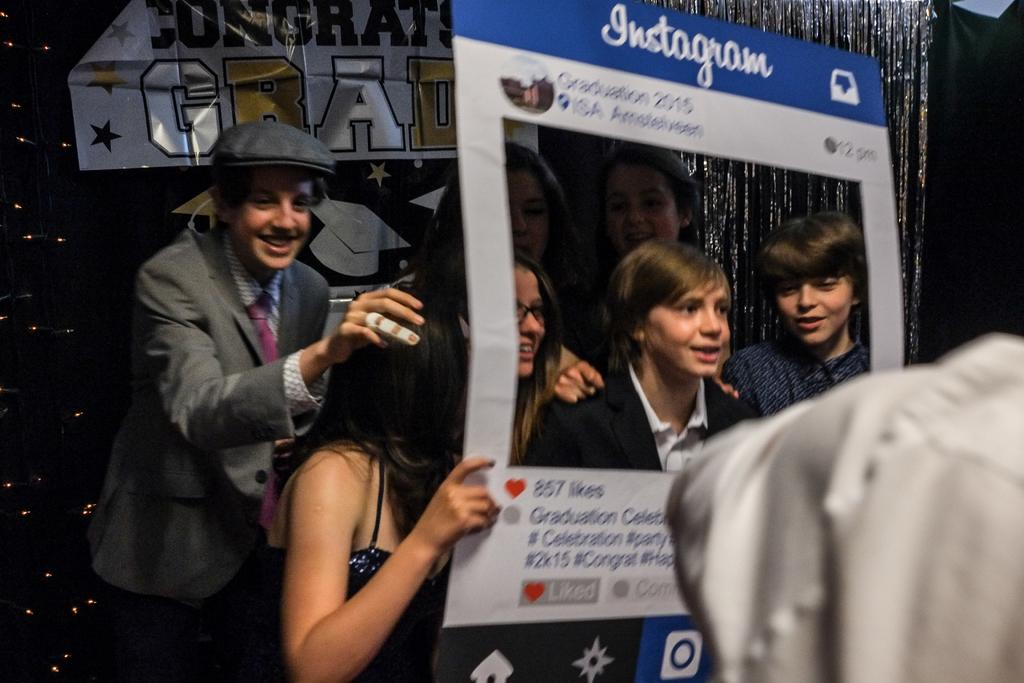How many people are in the image? There are people standing in the image. What is one person holding in the image? One person is holding a board. What type of objects can be seen in the image besides people? There are decorative items in the image. How would you describe the lighting in the image? The image appears to be dark. How many servants are present in the image? There is no mention of servants in the image, so we cannot determine their presence. What type of mice can be seen interacting with the decorative items in the image? There are no mice present in the image; it only features people and decorative items. 